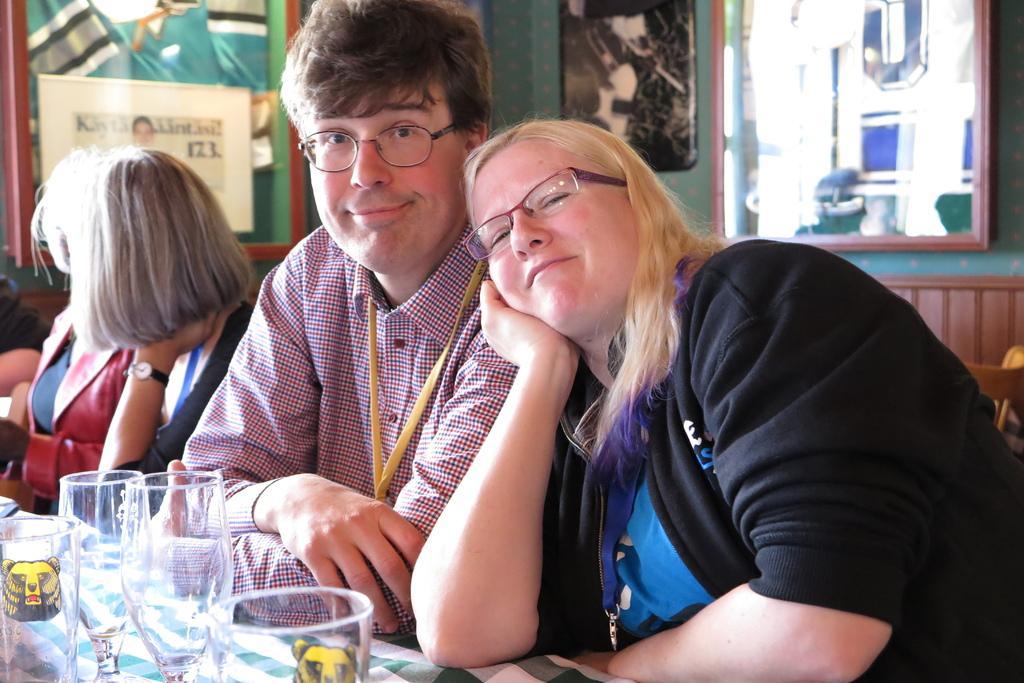In one or two sentences, can you explain what this image depicts? In this image I can see a man is there, he is wearing spectacles, shirt. Beside him there is a woman leaning on him, she is wearing a black color sweater. On the left side there are wine glasses on this stable, on the right side there is mirror on the wall. 